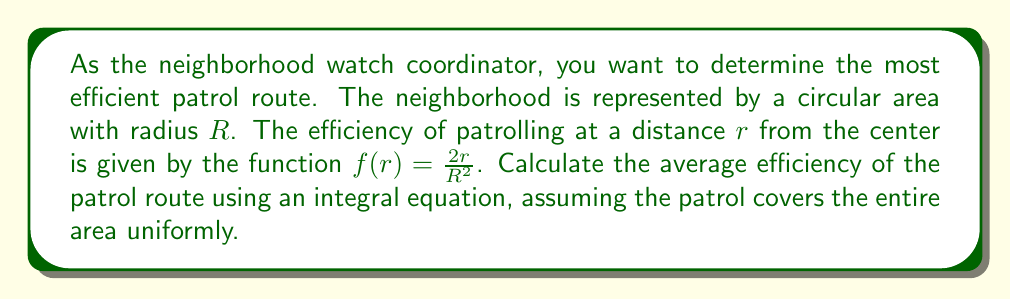Help me with this question. To solve this problem, we'll follow these steps:

1) The average efficiency can be calculated using the formula for the average value of a function over a region:

   $$\text{Average Efficiency} = \frac{\int_A f(r) dA}{\int_A dA}$$

   where $A$ is the area of the circular neighborhood.

2) In polar coordinates, $dA = r dr d\theta$. The limits for $r$ are from 0 to $R$, and for $\theta$ from 0 to $2\pi$.

3) Let's calculate the numerator first:

   $$\int_A f(r) dA = \int_0^{2\pi} \int_0^R \frac{2r}{R^2} \cdot r dr d\theta$$

4) Simplify:

   $$= \frac{2}{R^2} \int_0^{2\pi} \int_0^R r^2 dr d\theta$$

5) Solve the inner integral:

   $$= \frac{2}{R^2} \int_0^{2\pi} [\frac{r^3}{3}]_0^R d\theta = \frac{2}{R^2} \int_0^{2\pi} \frac{R^3}{3} d\theta$$

6) Solve the outer integral:

   $$= \frac{2}{R^2} \cdot \frac{R^3}{3} \cdot 2\pi = \frac{4\pi R}{3}$$

7) Now, let's calculate the denominator:

   $$\int_A dA = \int_0^{2\pi} \int_0^R r dr d\theta = 2\pi \cdot \frac{R^2}{2} = \pi R^2$$

8) Finally, divide the numerator by the denominator:

   $$\text{Average Efficiency} = \frac{\frac{4\pi R}{3}}{\pi R^2} = \frac{4}{3R}$$
Answer: $\frac{4}{3R}$ 